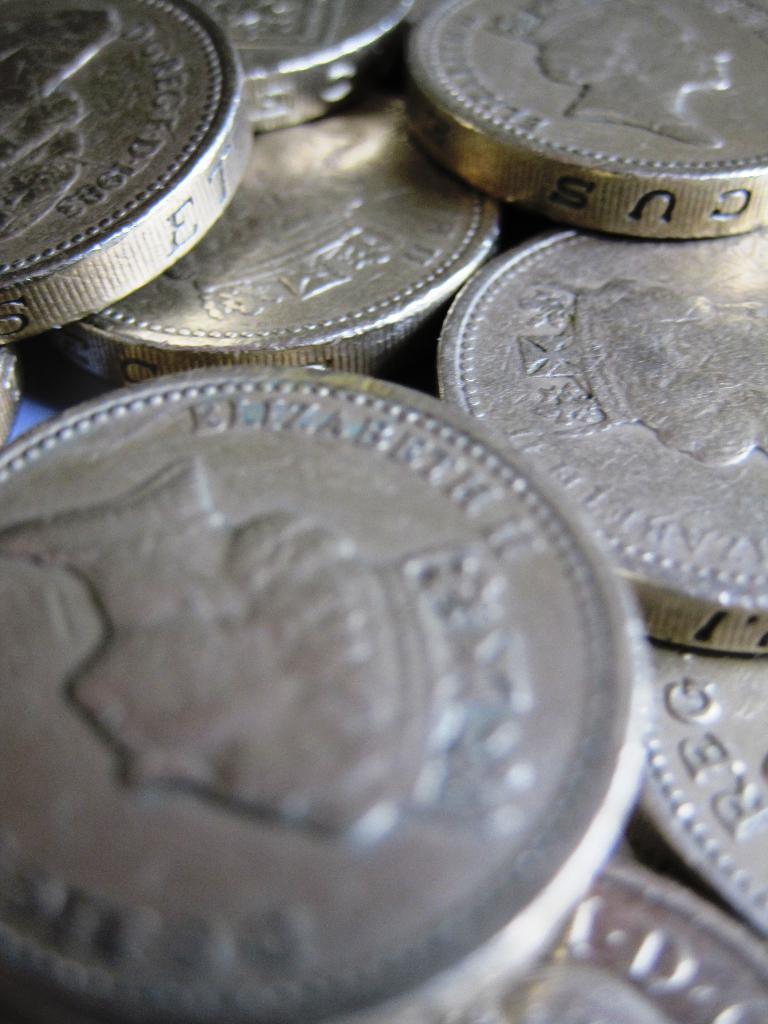What queen is on the coin?
Ensure brevity in your answer.  Elizabeth ii. Which queen is that?
Give a very brief answer. Elizabeth ii. 